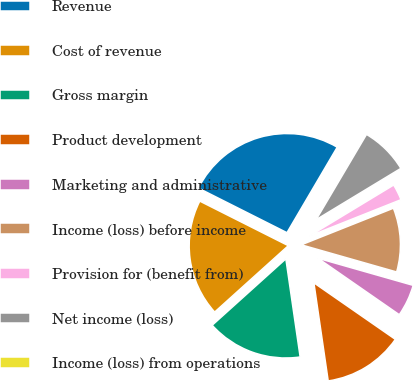Convert chart. <chart><loc_0><loc_0><loc_500><loc_500><pie_chart><fcel>Revenue<fcel>Cost of revenue<fcel>Gross margin<fcel>Product development<fcel>Marketing and administrative<fcel>Income (loss) before income<fcel>Provision for (benefit from)<fcel>Net income (loss)<fcel>Income (loss) from operations<nl><fcel>26.03%<fcel>19.1%<fcel>15.63%<fcel>13.04%<fcel>5.24%<fcel>10.44%<fcel>2.64%<fcel>7.84%<fcel>0.04%<nl></chart> 